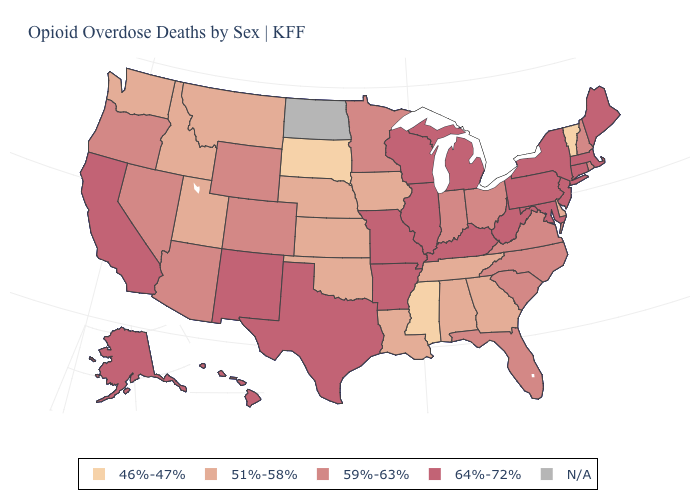Is the legend a continuous bar?
Concise answer only. No. What is the value of South Dakota?
Concise answer only. 46%-47%. How many symbols are there in the legend?
Short answer required. 5. What is the value of Hawaii?
Give a very brief answer. 64%-72%. Name the states that have a value in the range 59%-63%?
Keep it brief. Arizona, Colorado, Florida, Indiana, Minnesota, Nevada, New Hampshire, North Carolina, Ohio, Oregon, Rhode Island, South Carolina, Virginia, Wyoming. Does Kentucky have the highest value in the USA?
Keep it brief. Yes. Which states have the highest value in the USA?
Quick response, please. Alaska, Arkansas, California, Connecticut, Hawaii, Illinois, Kentucky, Maine, Maryland, Massachusetts, Michigan, Missouri, New Jersey, New Mexico, New York, Pennsylvania, Texas, West Virginia, Wisconsin. What is the highest value in the USA?
Answer briefly. 64%-72%. Which states have the highest value in the USA?
Concise answer only. Alaska, Arkansas, California, Connecticut, Hawaii, Illinois, Kentucky, Maine, Maryland, Massachusetts, Michigan, Missouri, New Jersey, New Mexico, New York, Pennsylvania, Texas, West Virginia, Wisconsin. What is the lowest value in states that border Delaware?
Concise answer only. 64%-72%. Among the states that border West Virginia , does Ohio have the lowest value?
Concise answer only. Yes. What is the highest value in the South ?
Quick response, please. 64%-72%. What is the value of Mississippi?
Be succinct. 46%-47%. What is the highest value in states that border New Hampshire?
Concise answer only. 64%-72%. 